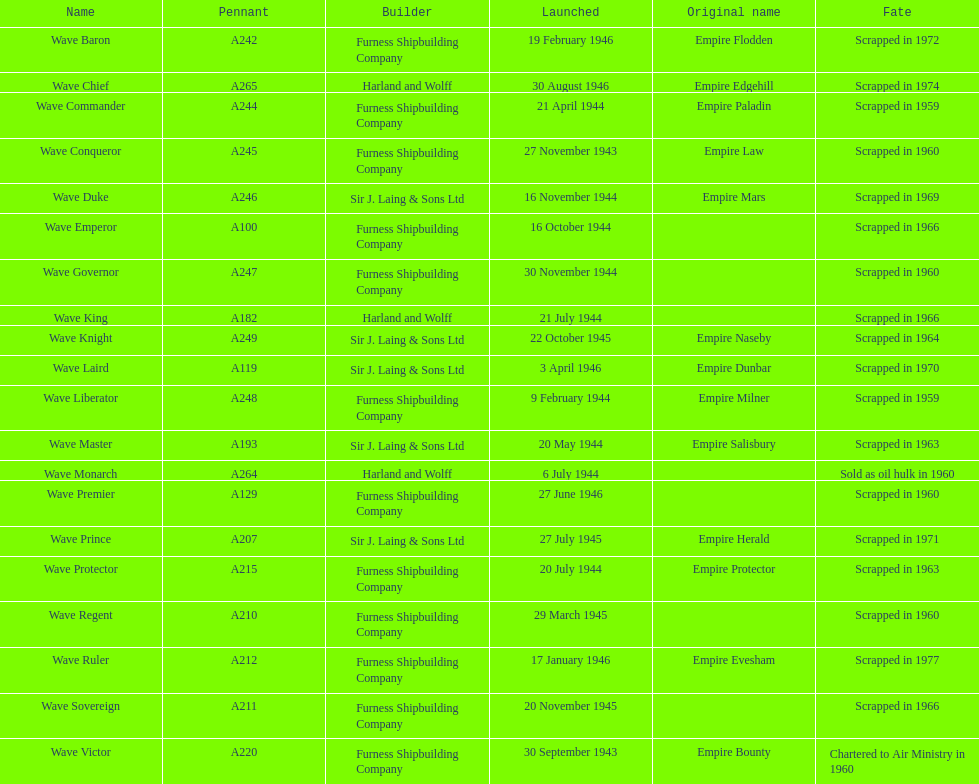What date was the first ship launched? 30 September 1943. 